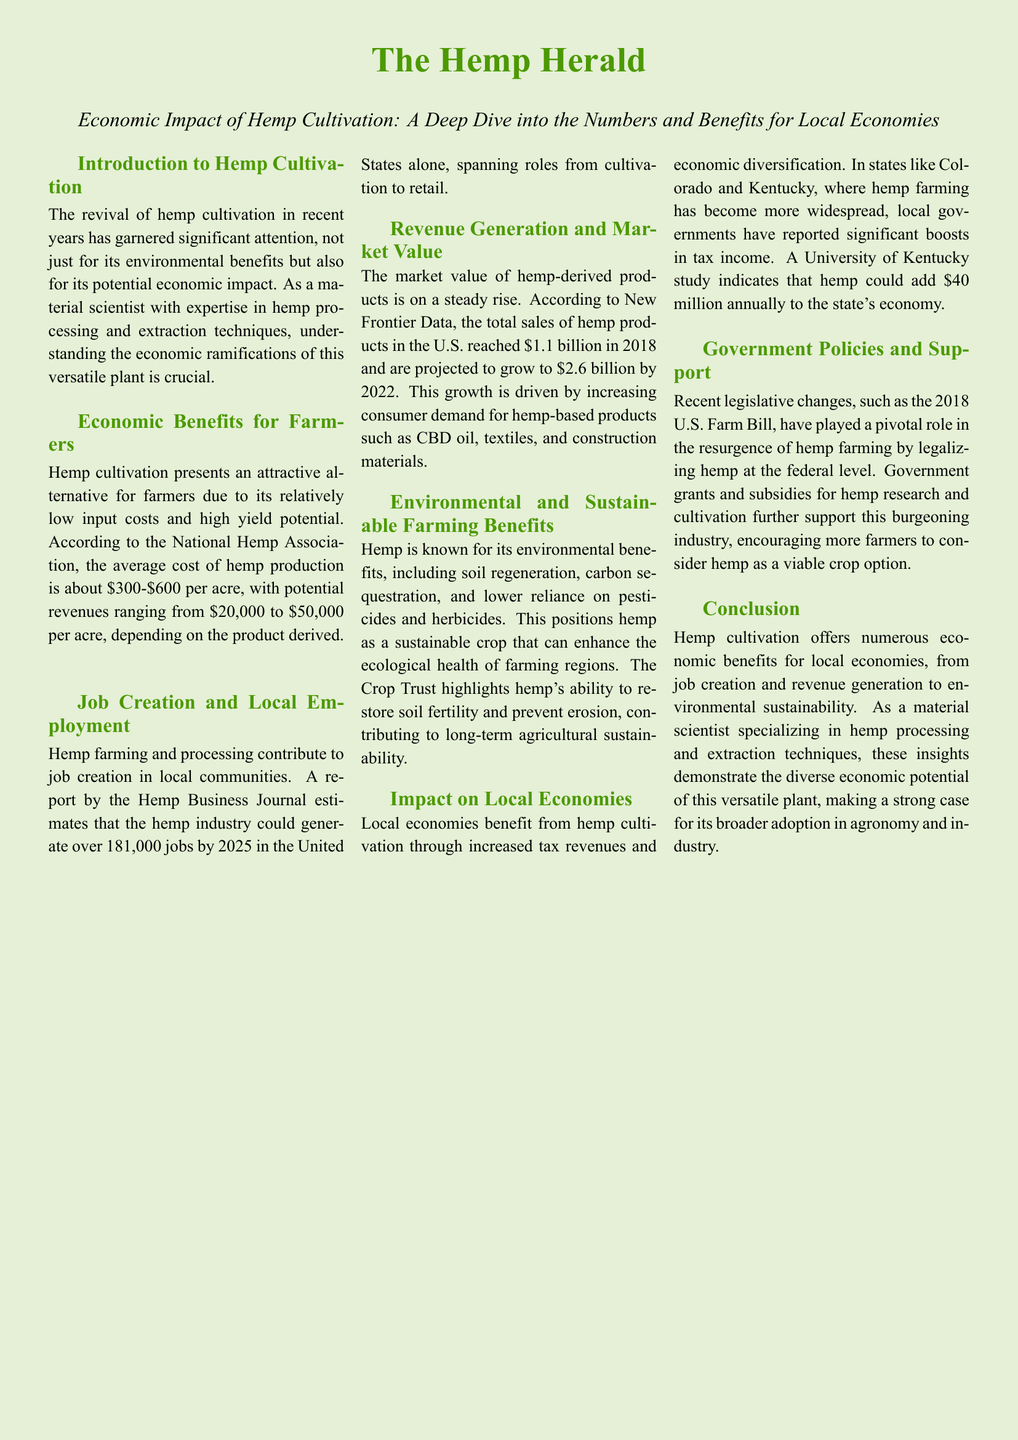What is the average cost of hemp production per acre? The document states that the average cost of hemp production is about $300-$600 per acre.
Answer: $300-$600 How many jobs could the hemp industry generate by 2025? According to a report by the Hemp Business Journal, the hemp industry could generate over 181,000 jobs by 2025.
Answer: 181,000 What was the total sales of hemp products in the U.S. in 2018? The document mentions that the total sales of hemp products in the U.S. reached $1.1 billion in 2018.
Answer: $1.1 billion What is one environmental benefit of hemp mentioned in the document? The document highlights lower reliance on pesticides and herbicides as one of the environmental benefits of hemp.
Answer: Lower reliance on pesticides and herbicides How much could hemp add to Kentucky's economy annually according to the University of Kentucky study? The University of Kentucky study indicates that hemp could add $40 million annually to the state's economy.
Answer: $40 million What significant legislative change occurred in 2018 regarding hemp? The document states that the 2018 U.S. Farm Bill played a pivotal role in the resurgence of hemp farming by legalizing hemp at the federal level.
Answer: Legalizing hemp at the federal level What color is used for the document title? The title color used in the document is described as hemp green.
Answer: Hemp green Which organization reported the job creation estimates for the hemp industry? The organization that estimated job creation in the document is the Hemp Business Journal.
Answer: Hemp Business Journal 